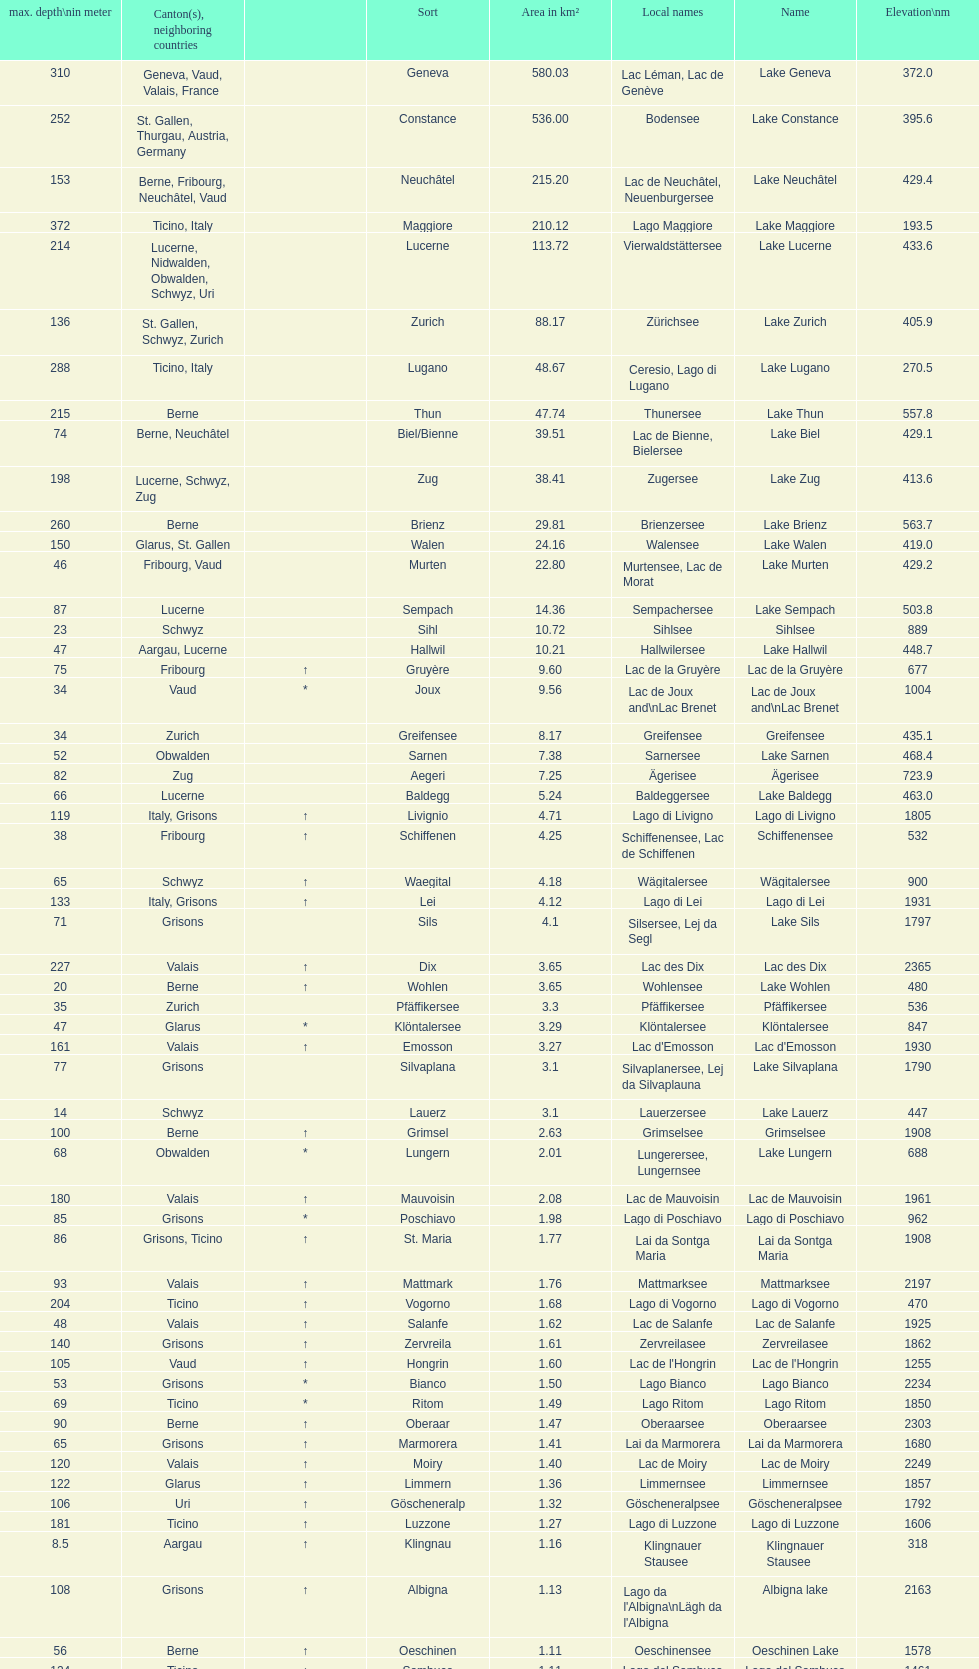What's the total max depth of lake geneva and lake constance combined? 562. 